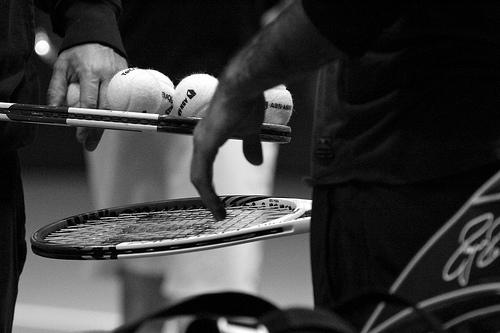Detail the central part of the image and its relevance to the overall scene. The man holding the tennis racket full of balls is the central part of the image, emphasizing the idea that he is involved in a tennis-related activity. Describe the central figure in the image and what they are associated with. The central figure is a man holding a tennis racket filled with balls, indicating his association with the sport of tennis. Talk about the primary object in the image and any related actions. The main object is the tennis racket filled with balls, held by a man who is also grasping one ball in his hand and carries a black bag. Provide a brief description of the primary object in the picture and any related actions. A person is holding a white tennis racket filled with various tennis balls, while also holding a black bag with a strap. Write a short overview of the image and its components. An individual is holding a tennis racket with multiple balls, one of which is in their hand, while wearing a black sweater and having a black bag strap around their arm. Explain the evident situation in the image and any objects connected to that situation. The situation is of a man getting ready to practice or play tennis, as he holds a racket with tennis balls and carries a black bag. What is the focal point in the image, and what it is used for? The focal point is the tennis racket filled with tennis balls, used for practicing or playing tennis. Describe the most important aspect of the image along with what it tells us about the scene. The image shows a man holding a tennis racket filled with tennis balls, indicating that he is possibly preparing to practice or play a game of tennis. Summarize the main activity taking place in the image. A person is about to engage in a tennis-related activity, as they grasp a racket full of tennis balls and hold one ball in their hand. Mention the key elements of the image along with the actions associated with these elements. A man in a black sweater has a bag's strap around his arm, holding a tennis racket covered in tennis balls, and grasping one of the balls in his hand. 